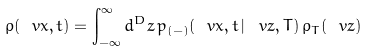Convert formula to latex. <formula><loc_0><loc_0><loc_500><loc_500>\rho ( \ v x , t ) = \int _ { - \infty } ^ { \infty } d ^ { D } z \, p _ { ( - ) } ( \ v x , t \, | \, \ v z , T ) \, \rho _ { T } ( \ v z )</formula> 